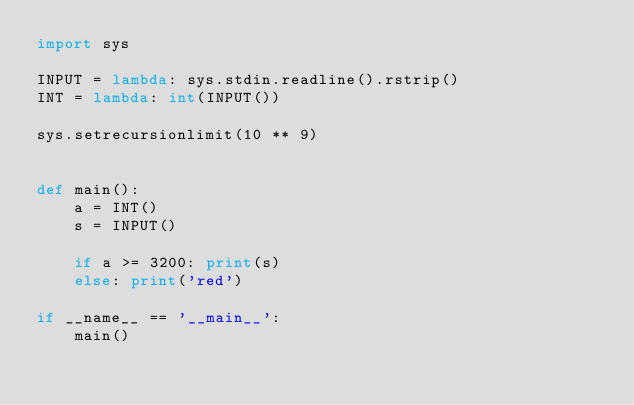Convert code to text. <code><loc_0><loc_0><loc_500><loc_500><_Python_>import sys

INPUT = lambda: sys.stdin.readline().rstrip()
INT = lambda: int(INPUT())

sys.setrecursionlimit(10 ** 9)


def main():
    a = INT()
    s = INPUT()

    if a >= 3200: print(s)
    else: print('red')

if __name__ == '__main__':
    main()
</code> 